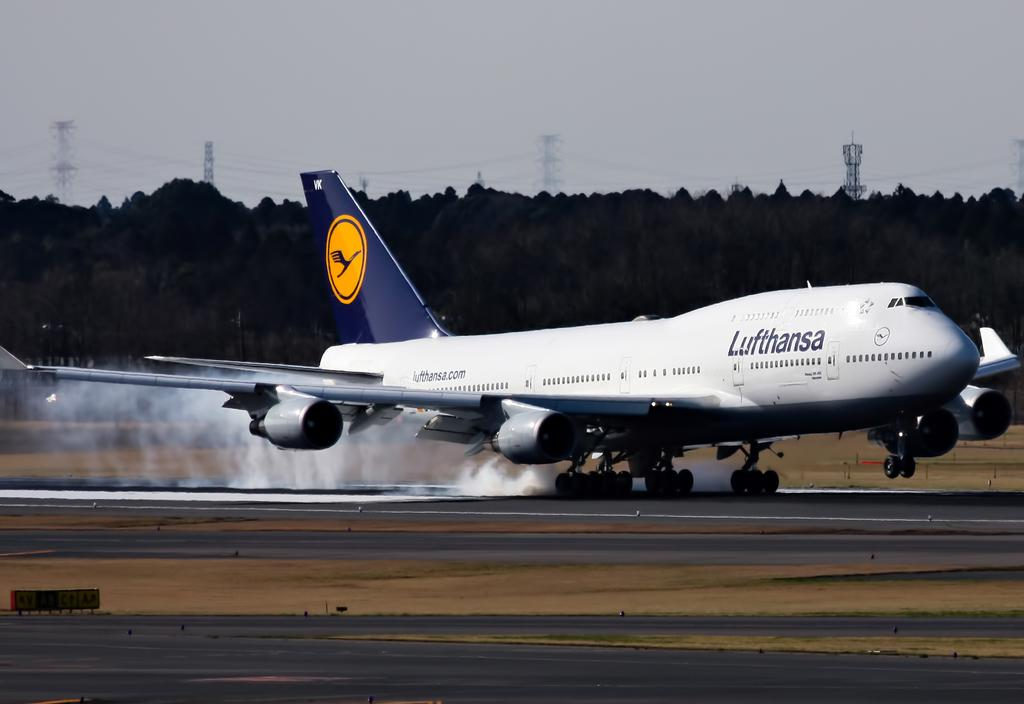<image>
Provide a brief description of the given image. Smoke comes off the tires as a Lufthansa plane lands on a runway. 